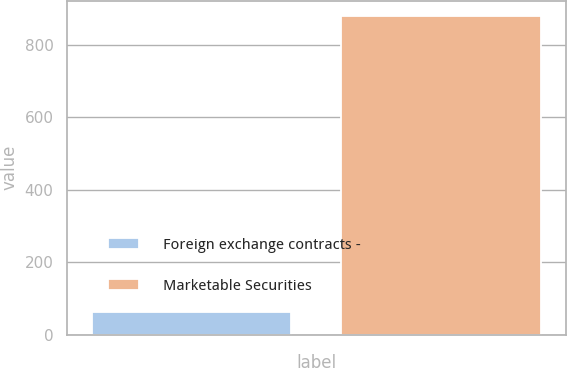<chart> <loc_0><loc_0><loc_500><loc_500><bar_chart><fcel>Foreign exchange contracts -<fcel>Marketable Securities<nl><fcel>64<fcel>878<nl></chart> 